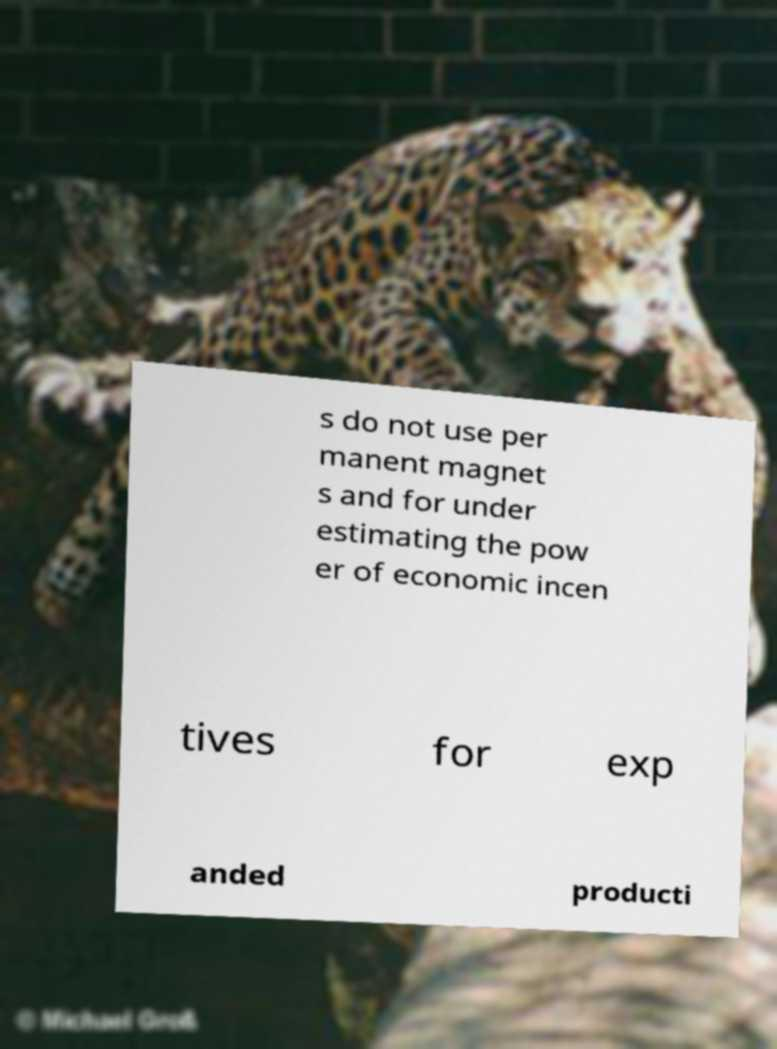Can you accurately transcribe the text from the provided image for me? s do not use per manent magnet s and for under estimating the pow er of economic incen tives for exp anded producti 